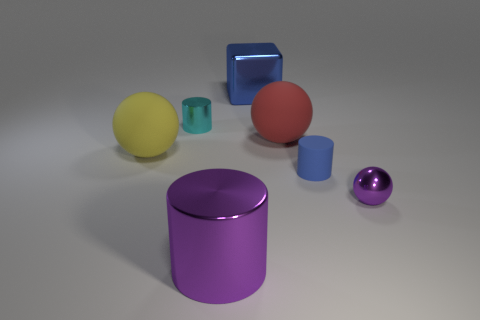The metallic ball is what color? The metallic ball in the image has a reflective purple surface that gives it a lustrous, shiny appearance. 